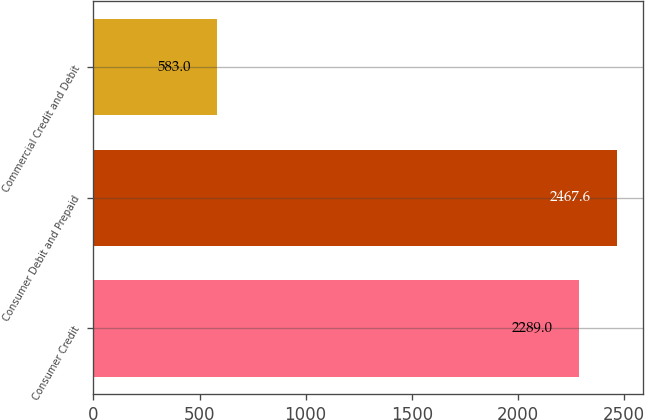Convert chart to OTSL. <chart><loc_0><loc_0><loc_500><loc_500><bar_chart><fcel>Consumer Credit<fcel>Consumer Debit and Prepaid<fcel>Commercial Credit and Debit<nl><fcel>2289<fcel>2467.6<fcel>583<nl></chart> 